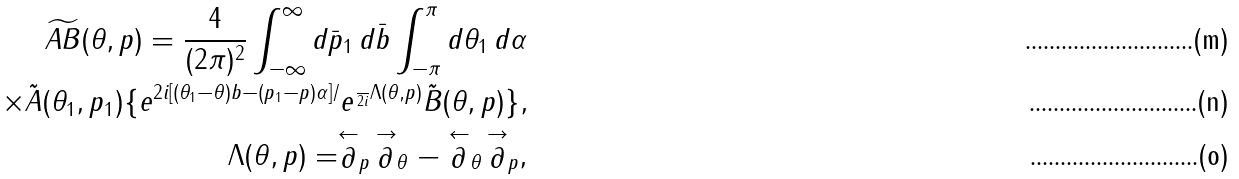<formula> <loc_0><loc_0><loc_500><loc_500>\widetilde { A B } ( \theta , p ) = \frac { 4 } { ( 2 \pi ) ^ { 2 } } \int _ { - \infty } ^ { \infty } d \bar { p } _ { 1 } \, d \bar { b } \int _ { - \pi } ^ { \pi } d \theta _ { 1 } \, d \alpha \\ \times \tilde { A } ( \theta _ { 1 } , p _ { 1 } ) \{ e ^ { 2 i [ ( \theta _ { 1 } - \theta ) b - ( p _ { 1 } - p ) \alpha ] / } e ^ { \frac { } { 2 i } \Lambda ( \theta , p ) } \tilde { B } ( \theta , p ) \} , \\ \Lambda ( \theta , p ) = \stackrel { \leftarrow } { \partial } _ { p } \, \stackrel { \rightarrow } { \partial } _ { \theta } - \stackrel { \leftarrow } { \partial } _ { \theta } \, \stackrel { \rightarrow } { \partial } _ { p } ,</formula> 